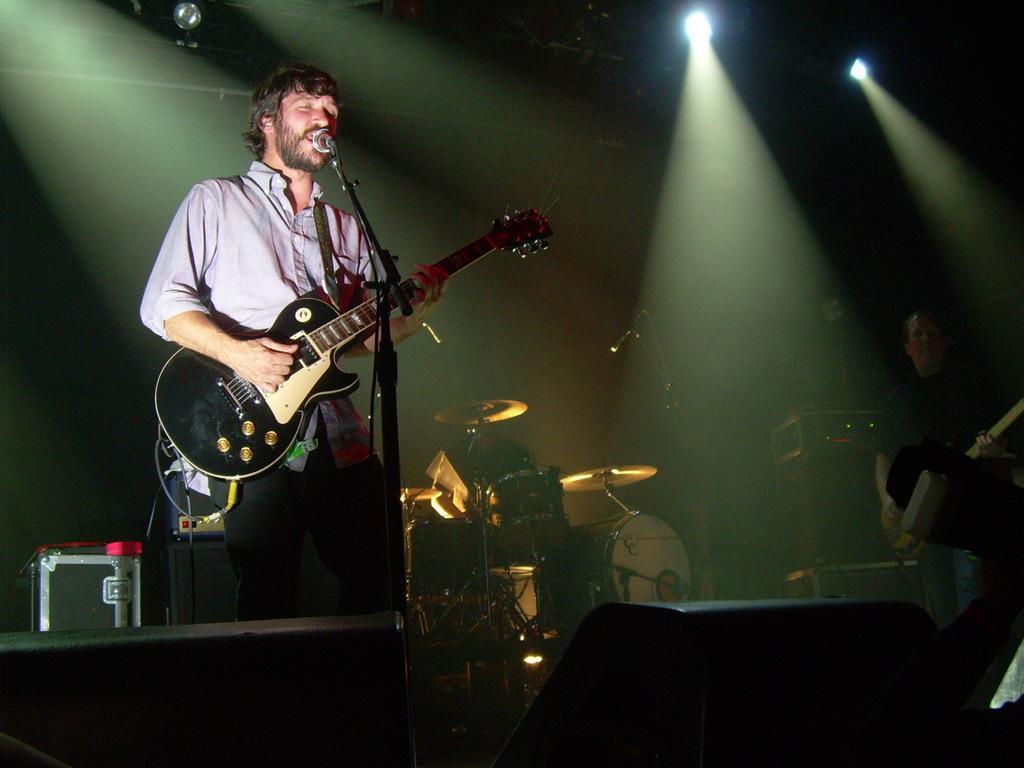Could you give a brief overview of what you see in this image? In this image i can see a person holding a guitar standing in front of a microphone. In the background i can see few musical instruments and a person. 